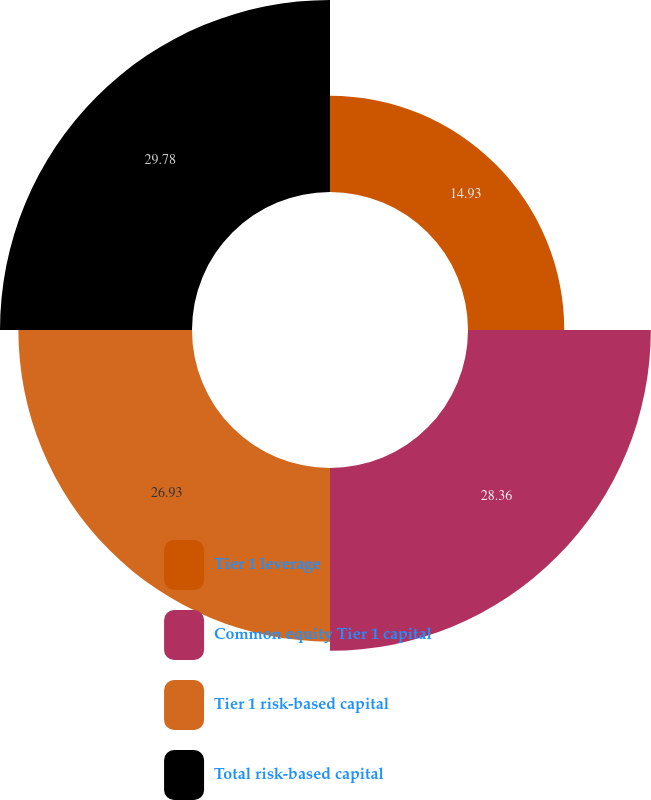<chart> <loc_0><loc_0><loc_500><loc_500><pie_chart><fcel>Tier 1 leverage<fcel>Common equity Tier 1 capital<fcel>Tier 1 risk-based capital<fcel>Total risk-based capital<nl><fcel>14.93%<fcel>28.36%<fcel>26.93%<fcel>29.78%<nl></chart> 